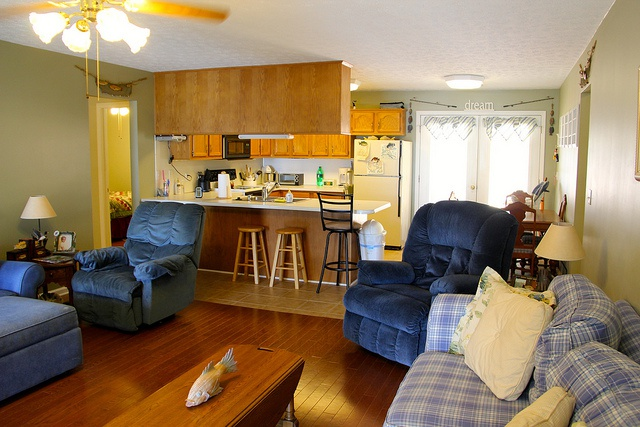Describe the objects in this image and their specific colors. I can see couch in darkgray, gray, and tan tones, chair in darkgray, black, navy, darkblue, and gray tones, chair in darkgray, black, blue, gray, and navy tones, couch in darkgray, black, and gray tones, and refrigerator in darkgray, khaki, beige, and tan tones in this image. 